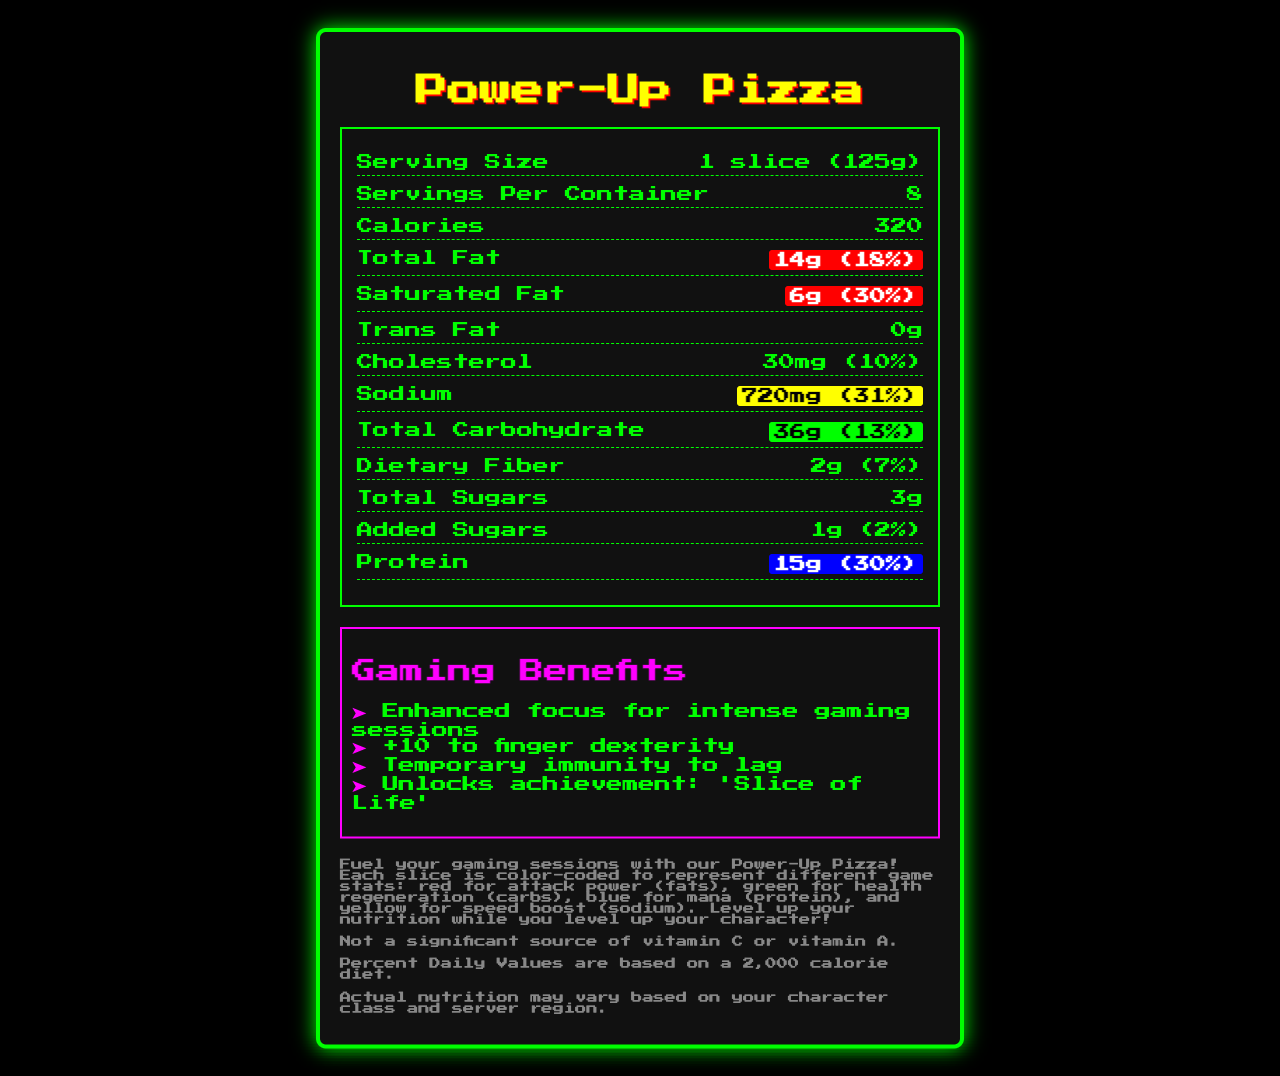what is the serving size of Power-Up Pizza? The serving size is listed at the top of the nutrition facts section.
Answer: 1 slice (125g) how many calories are there per serving? The calories per serving are indicated in the nutrition facts section.
Answer: 320 calories what percentage of daily value is total fat per serving? The document shows that total fat is 14g, which is 18% of the daily value.
Answer: 18% how much protein is in one slice of Power-Up Pizza? The nutrition facts indicate that there are 15 grams of protein per serving.
Answer: 15g what allergens are present in the Power-Up Pizza? The allergens are listed explicitly in the document under the allergens section.
Answer: Wheat, Milk, Soy what is the amount of sodium per serving? The document states that sodium content is 720mg per serving.
Answer: 720mg how much saturated fat does one slice contain? The nutrition facts display that each serving contains 6 grams of saturated fat.
Answer: 6g what are the total carbohydrates in one slice? The document states that total carbohydrates are 36 grams per serving.
Answer: 36g what are the gaming benefits of the Power-Up Pizza mentioned in the document? These benefits are listed under the gaming benefits section in the document.
Answer: Enhanced focus for intense gaming sessions, +10 to finger dexterity, Temporary immunity to lag, Unlocks achievement: 'Slice of Life' which macronutrient is represented by the blue color? A. Fat B. Carbohydrate C. Protein D. Sodium The document states that blue represents protein in the description.
Answer: C. Protein how many servings are in one container of Power-Up Pizza? A. 6 B. 8 C. 10 D. 12 The servings per container are specified as 8 in the nutrition facts section.
Answer: B. 8 does the Power-Up Pizza contain any trans fat? The document shows that trans fat content is 0g per serving.
Answer: No is this product a significant source of vitamin C? The disclaimer mentions that it is not a significant source of vitamin C or vitamin A.
Answer: No describe the main idea of the Power-Up Pizza nutrition facts document. The document details nutritional facts, describes gaming benefits, uses color-coded sections for fats, carbs, protein, and sodium, lists allergens, and includes disclaimers.
Answer: The document provides detailed nutritional information about the Power-Up Pizza, including serving size, calories, macronutrients, and micronutrients. It also describes the gaming-themed benefits of the pizza, uses color coding for macronutrients, lists allergens, and includes various disclaimers. what is the proportion of daily value of saturated fat to the total fat daily value? The document indicates that saturated fat makes up 30% of the daily value, while total fat is 18%, meaning saturated fat is a significant portion of the total fat.
Answer: One-third or 30% to 18% what does the term "Gamer Fuel energy drink powder" refer to? The term "Gamer Fuel energy drink powder" is listed as an ingredient, but the document doesn't provide further details about it.
Answer: Not enough information 